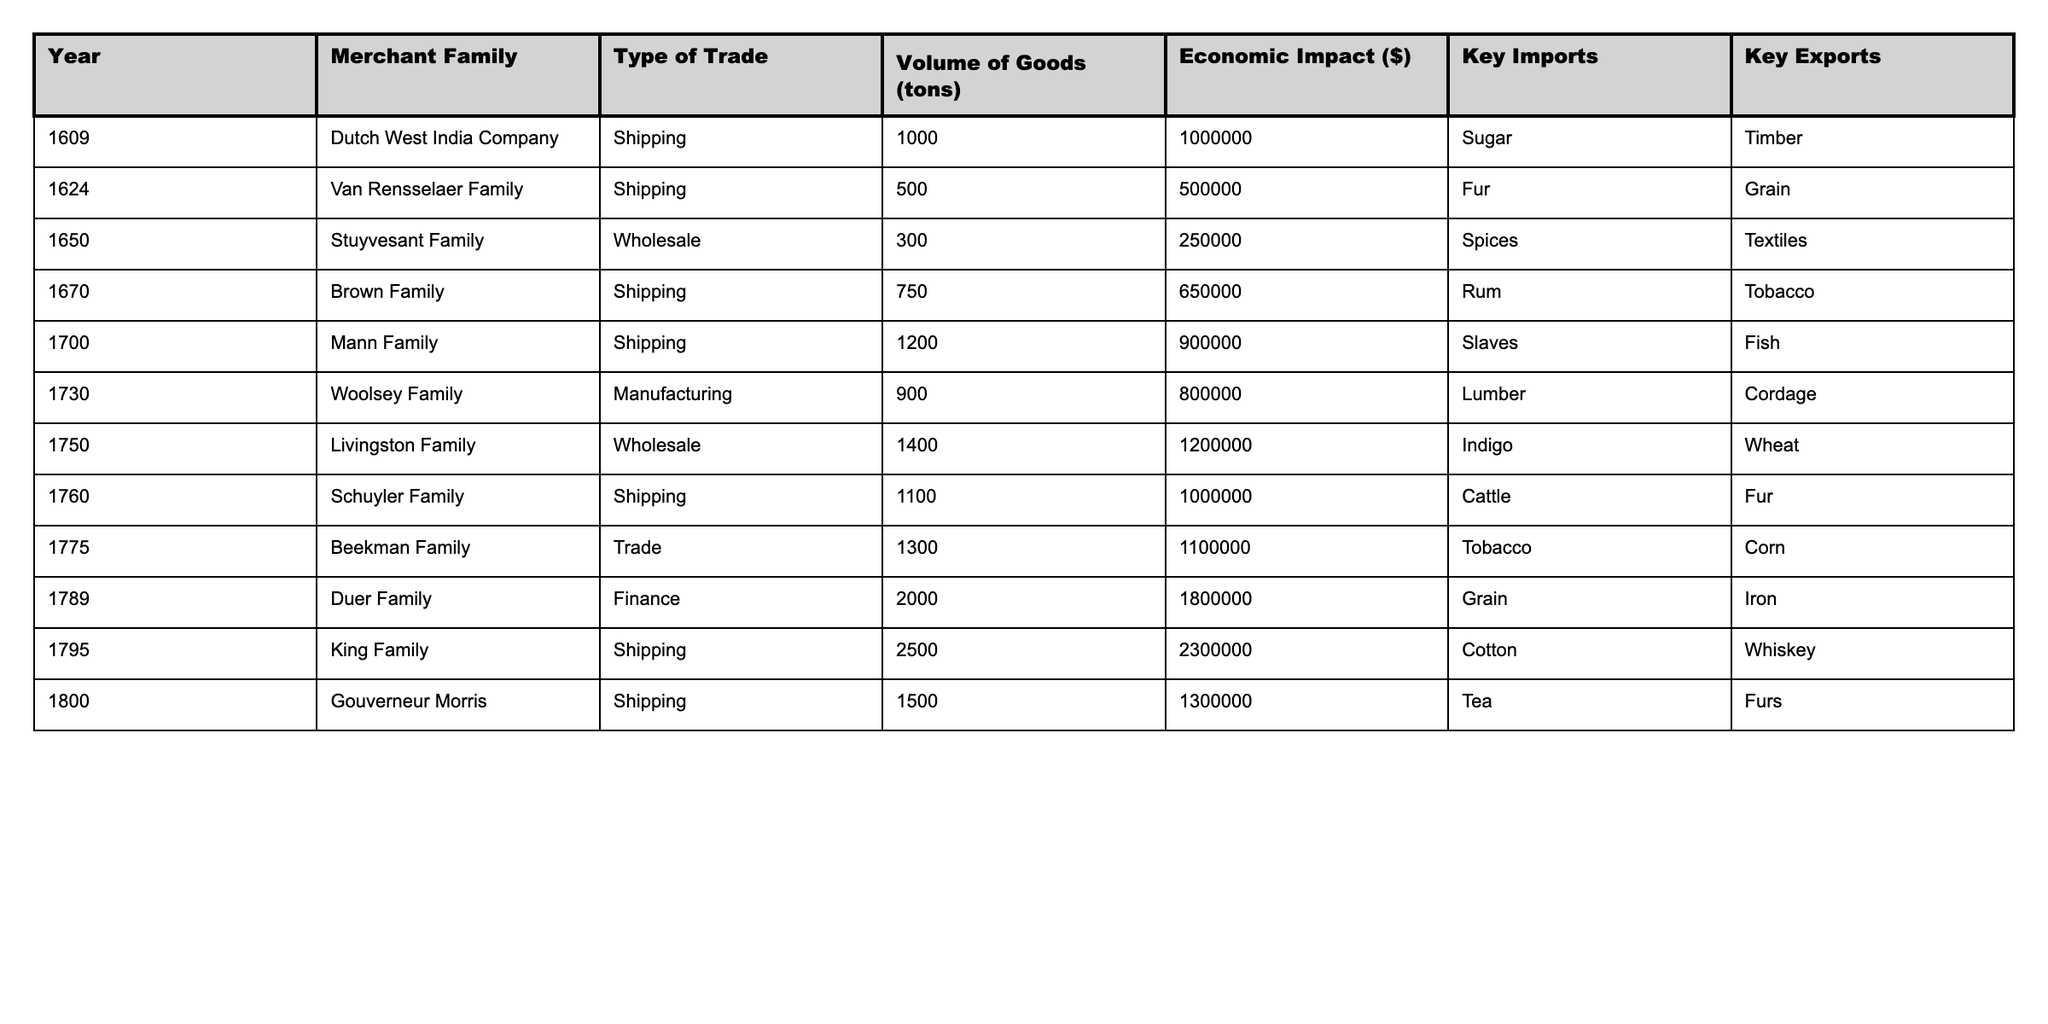What was the volume of goods traded by the Brown Family in 1670? The table shows that the Brown Family had a volume of goods traded of 750 tons in the year 1670.
Answer: 750 tons Which merchant family had the highest economic impact and what was the amount? The table indicates that the King Family had the highest economic impact of $2,300,000 in 1795.
Answer: $2,300,000 True or False: The Mann Family was involved in manufacturing activity. According to the table, the Mann Family was engaged in shipping in 1700, not manufacturing.
Answer: False What is the total economic impact of all merchant families listed in the table? To find the total economic impact, sum the economic impacts of all families: 1,000,000 + 500,000 + 250,000 + 650,000 + 900,000 + 800,000 + 1,200,000 + 1,100,000 + 1,800,000 + 2,300,000 + 1,300,000 = $12,000,000.
Answer: $12,000,000 What was the average volume of goods traded by the merchant families that exported tobacco? The relevant families that exported tobacco are the Brown Family (750 tons), the Beekman Family (1300 tons), and the Mann Family (1200 tons). The average volume is calculated as (750 + 1300 + 1200) / 3 = 850 tons.
Answer: 850 tons Which year saw the least volume of goods traded and what was it? Reviewing the table, the year with the least volume of goods traded is 1624 with 500 tons by the Van Rensselaer Family.
Answer: 500 tons In what type of trade was the Duer Family involved in 1789? The table indicates that the Duer Family was involved in finance in the year 1789.
Answer: Finance Which key export was consistent across multiple merchant families? Upon examining the table, "Fur" appears as a key export for both the Stuyvesant and Schuyler Families.
Answer: Fur What was the difference in economic impact between the highest and lowest merchant family in the year 1730? The Woolsey Family had an economic impact of $800,000 in 1730; there is no lower family within the same year in the presented data, so we compare it against available years, but the lowest for any single year is the Van Rensselaer Family with $500,000 in 1624. Thus, $800,000 - $500,000 = $300,000.
Answer: $300,000 How many merchant families exported grain according to the table? The Duer Family in 1789 and the Van Rensselaer Family in 1624 both exported grain, which totals to two families.
Answer: 2 families 